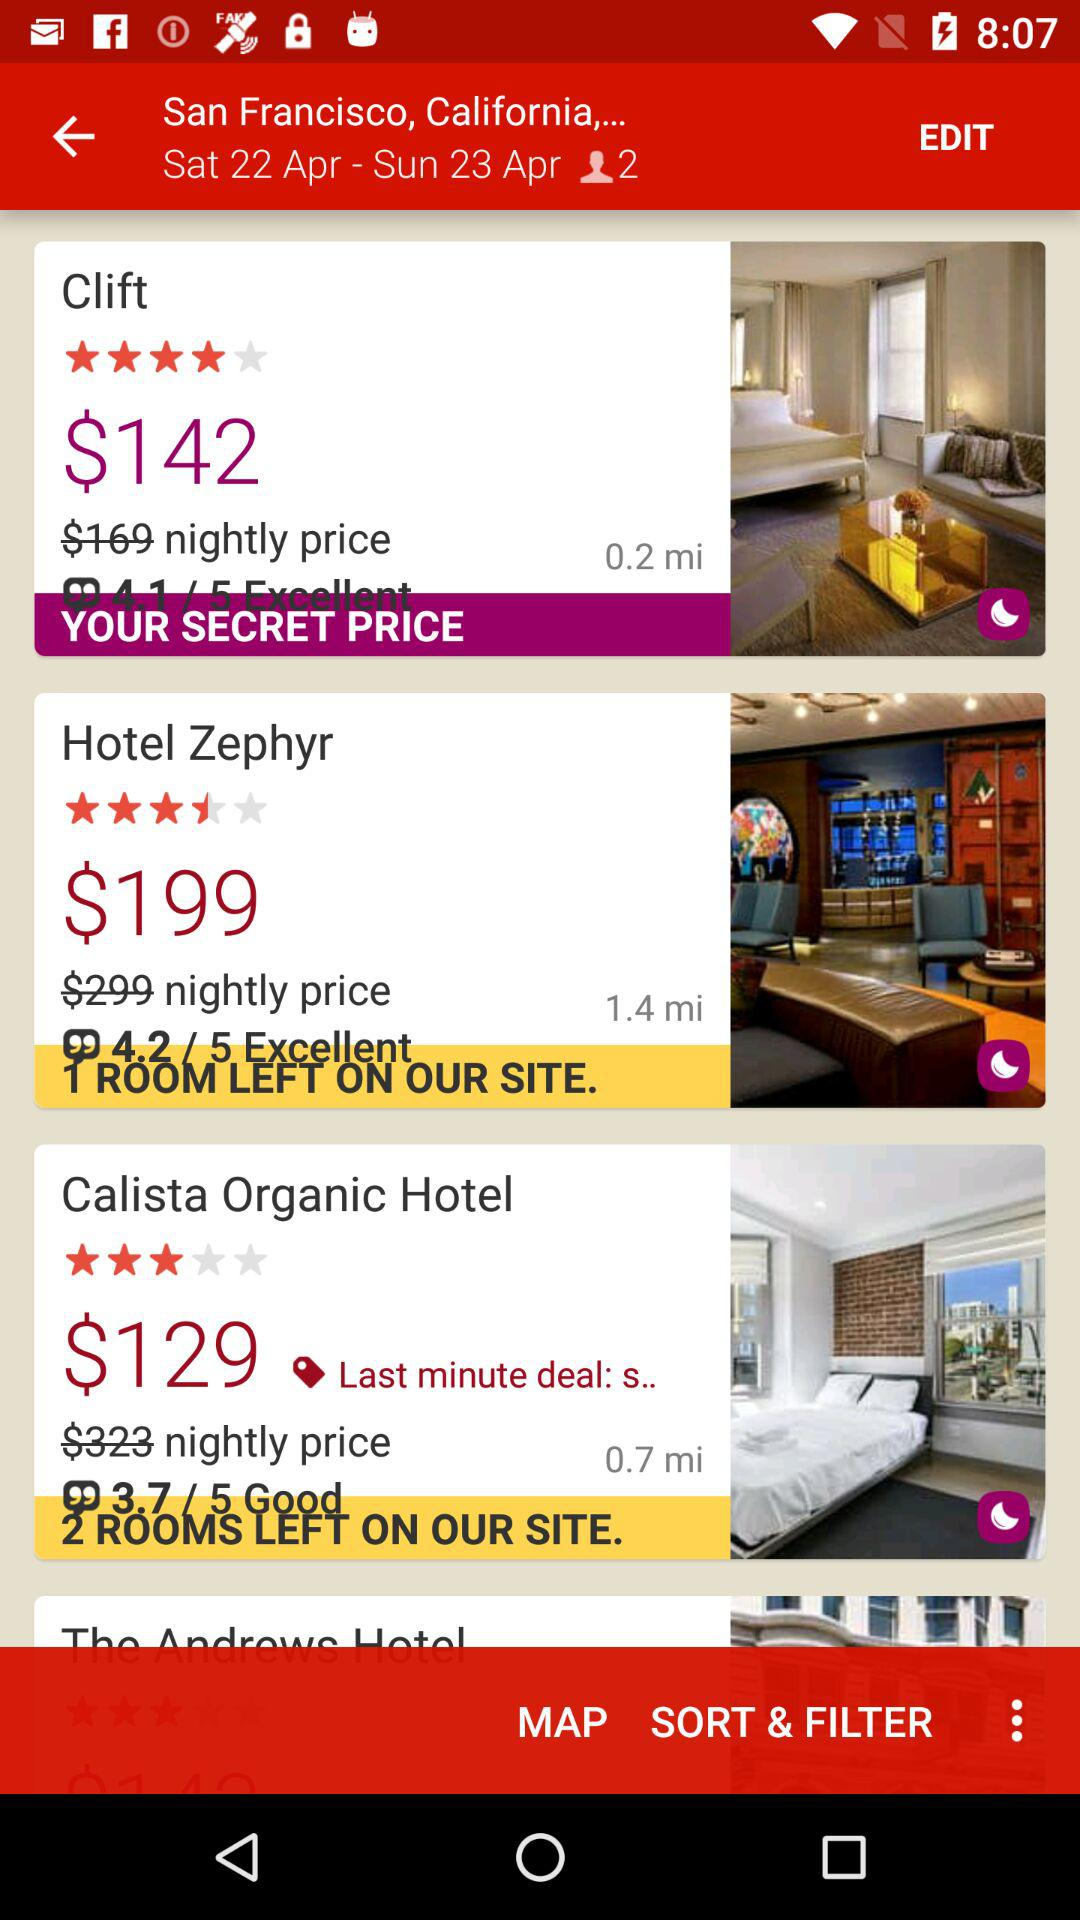How many miles away is Clift? Clift is 0.2 miles away. 